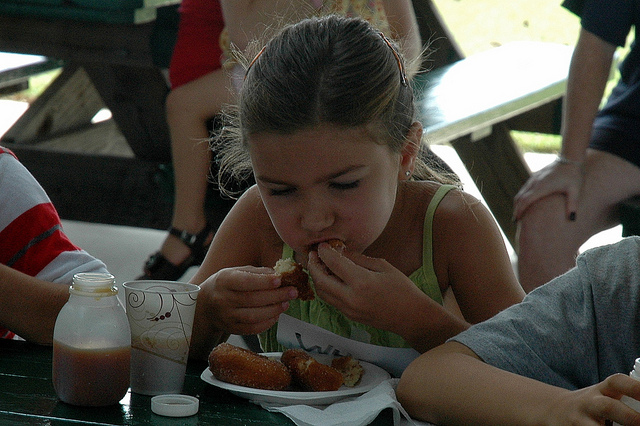How many people are there? In the image, I can only clearly identify one person, a young girl who seems to be enjoying some food at a picnic table. 